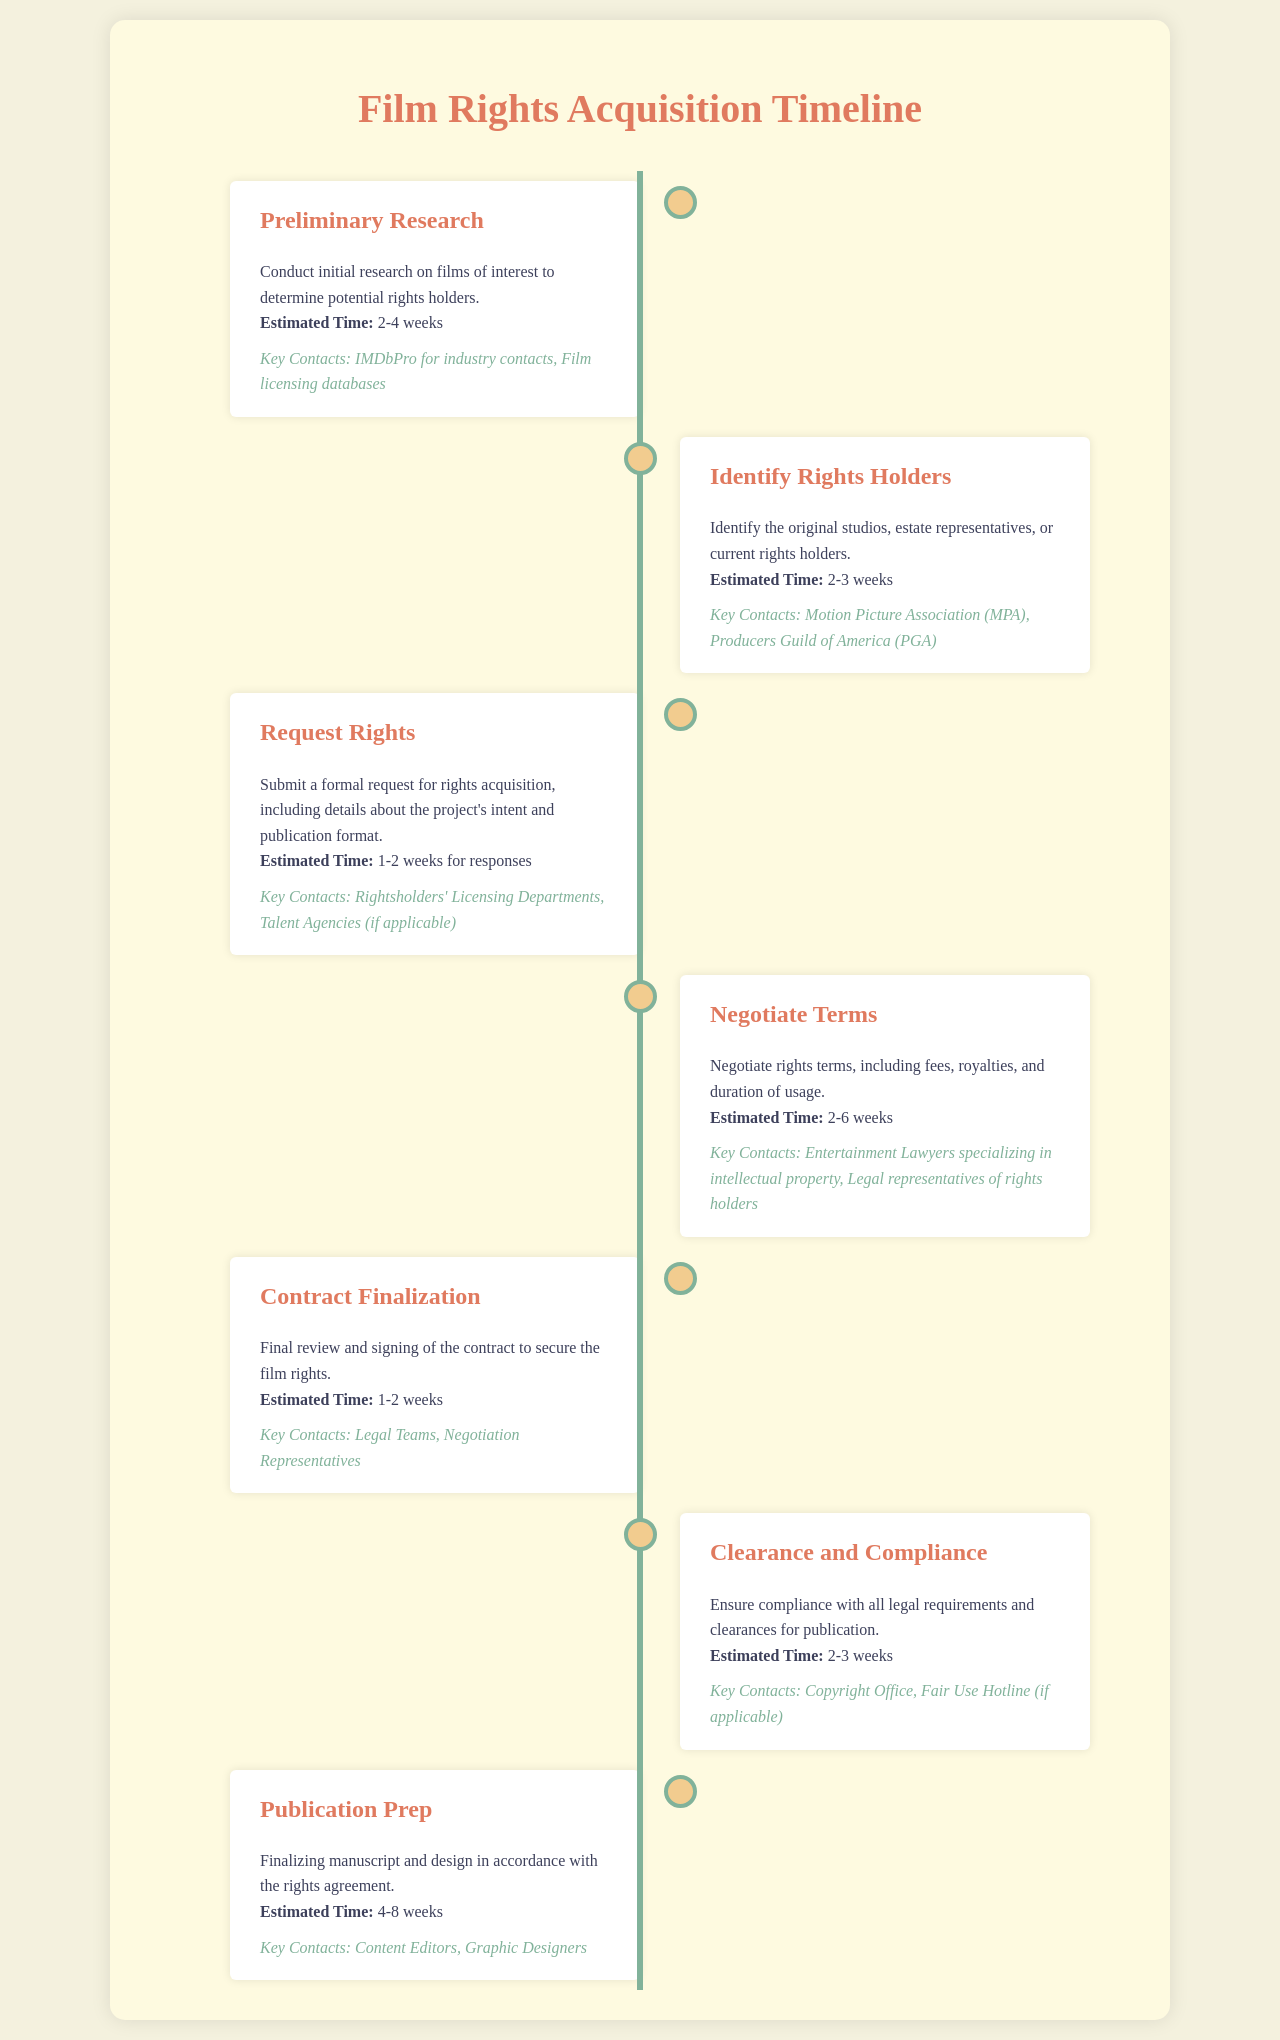what is the estimated time for preliminary research? The estimated time for preliminary research is provided in the document, which states it takes 2-4 weeks.
Answer: 2-4 weeks who are the key contacts for identifying rights holders? The document lists key contacts for identifying rights holders, including the Motion Picture Association and Producers Guild of America.
Answer: Motion Picture Association, Producers Guild of America how long does contract finalization take? The document specifies that contract finalization takes 1-2 weeks.
Answer: 1-2 weeks what is the purpose of the 'Request Rights' phase? The document explains that the purpose of the 'Request Rights' phase is to submit a formal request for rights acquisition.
Answer: Submit a formal request for rights acquisition what is the maximum estimated time for publication preparation? The document states the estimated time for publication preparation is between 4 to 8 weeks, with 8 being the maximum time.
Answer: 8 weeks which department should be contacted during the clearance and compliance phase? According to the document, the Copyright Office is a key contact during the clearance and compliance phase.
Answer: Copyright Office how does the timeline for negotiating terms compare to the timeline for requesting rights? The document indicates that negotiating terms takes longer at 2-6 weeks, whereas requesting rights takes 1-2 weeks.
Answer: 2-6 weeks vs 1-2 weeks what is the main focus of the publication prep stage? The document specifies that the main focus of the publication prep stage is finalizing manuscript and design.
Answer: Finalizing manuscript and design what should be ensured during clearance and compliance? The document highlights that compliance with all legal requirements and clearances for publication should be ensured.
Answer: Compliance with legal requirements and clearances 